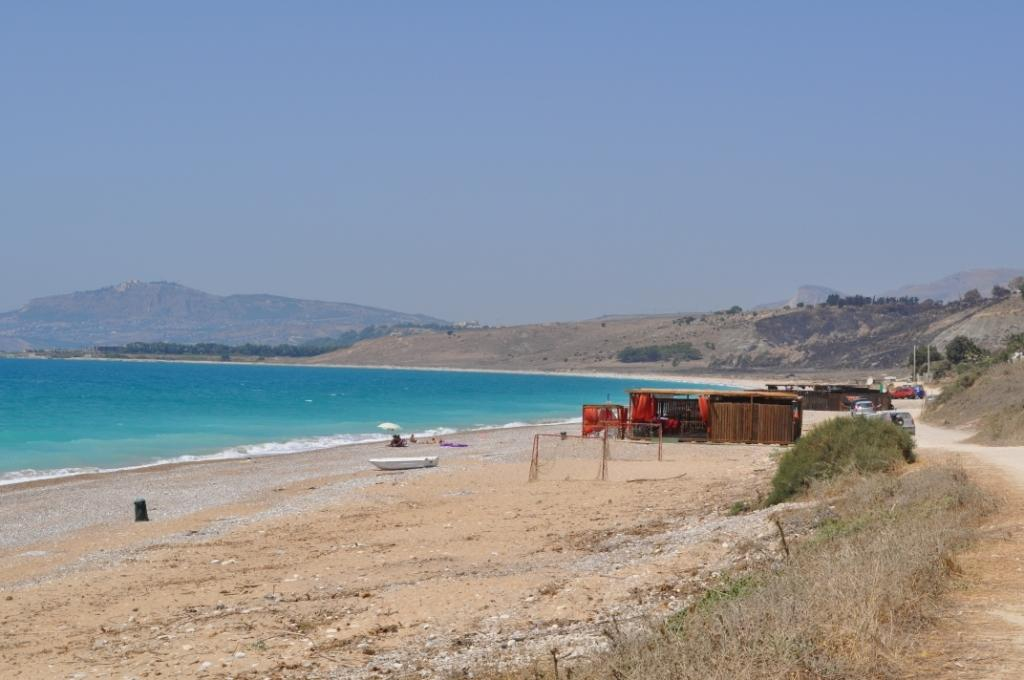What is the primary element visible in the image? There is water in the image. What type of vehicle can be seen in the image? There are vehicles in the image. What type of natural environment is depicted in the image? The image features trees, hills, grass, and sky. What type of structure is present in the image? There are shelters in the image. What is the boat's purpose in the image? The boat is likely used for transportation or recreation on the water. How many objects are visible in the image? There are objects in the image, but the exact number is not specified. What type of pot is being advertised in the image? There is no pot or advertisement present in the image. 